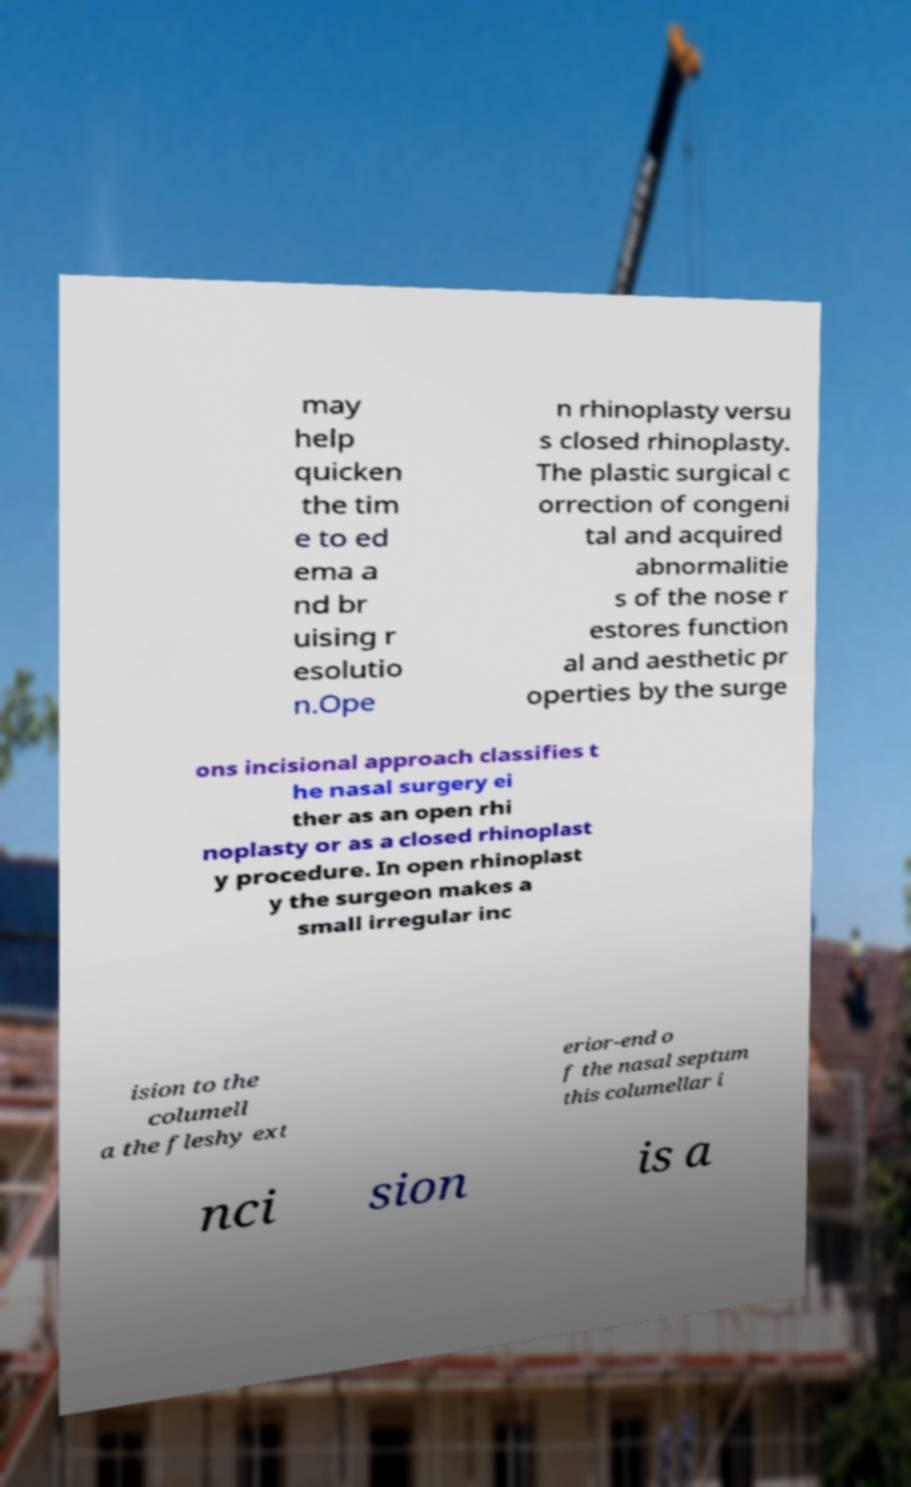Can you read and provide the text displayed in the image?This photo seems to have some interesting text. Can you extract and type it out for me? may help quicken the tim e to ed ema a nd br uising r esolutio n.Ope n rhinoplasty versu s closed rhinoplasty. The plastic surgical c orrection of congeni tal and acquired abnormalitie s of the nose r estores function al and aesthetic pr operties by the surge ons incisional approach classifies t he nasal surgery ei ther as an open rhi noplasty or as a closed rhinoplast y procedure. In open rhinoplast y the surgeon makes a small irregular inc ision to the columell a the fleshy ext erior-end o f the nasal septum this columellar i nci sion is a 